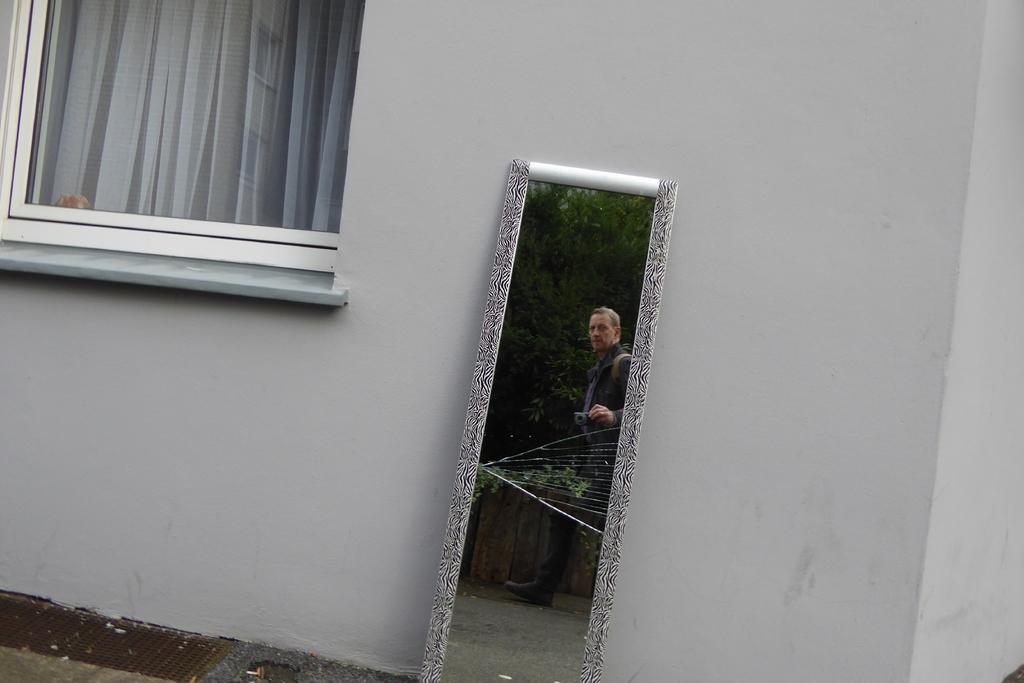Could you give a brief overview of what you see in this image? In the middle of the picture, we see a mirror in which we can see a man is walking. Beside him, we see a wooden fence and the trees. Behind the mirror, we see a white wall and a window. 